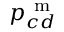Convert formula to latex. <formula><loc_0><loc_0><loc_500><loc_500>p _ { c d } ^ { m }</formula> 